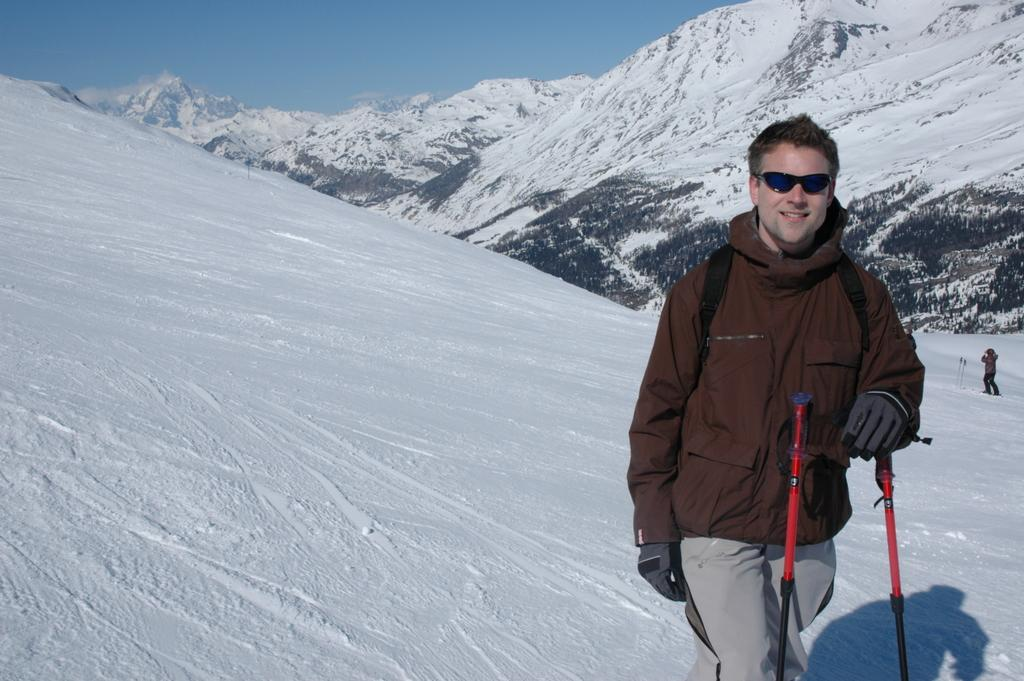What is the main subject of the image? There is a man in the image. What is the man doing in the image? The man is standing and holding a ski pole. What can be seen in the background of the image? There are snowy mountains and at least one person in the background of the image. What is visible at the top of the image? The sky is visible at the top of the image. What type of pail can be seen being used for washing in the image? There is no pail or washing activity present in the image. 